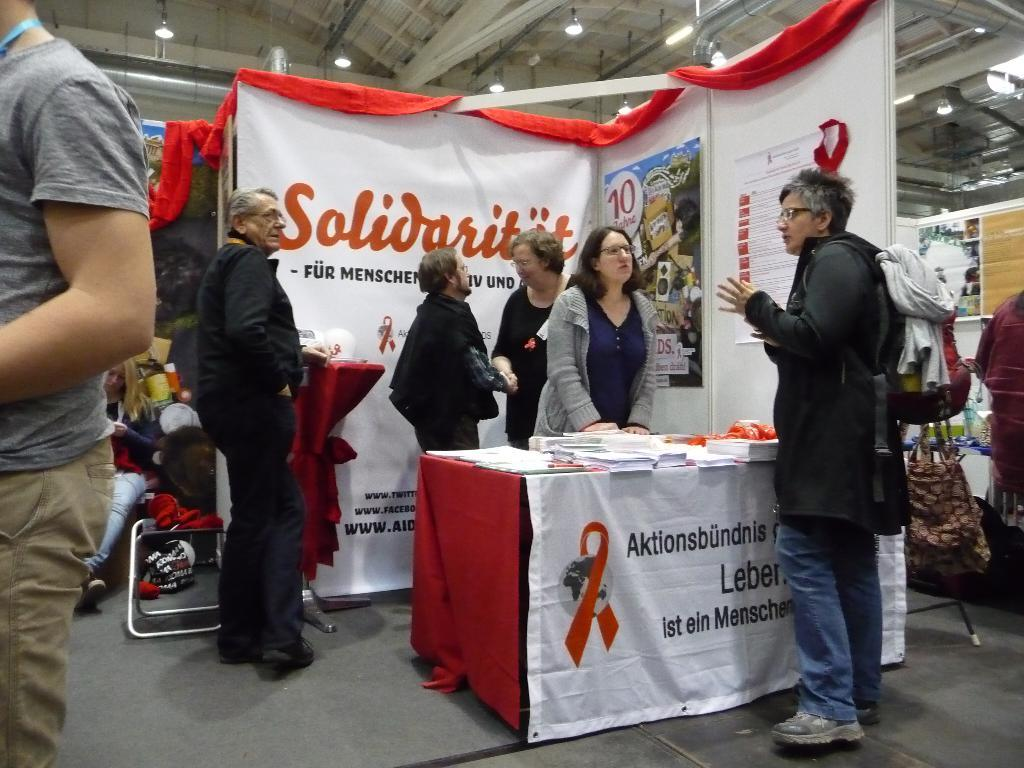What can be seen in the image involving people? There are people standing in the image. What objects are present in the image that might be used for seating or eating? There are tables in the image. What items are placed on the tables? Books are placed on the tables. What type of shelter is visible in the image? There is a tent in the image. What is the purpose of the board in the image? The purpose of the board in the image is not clear from the facts provided. What type of material is present in the image? There is cloth in the image. What type of container is visible in the image? There is a bag in the image. What is visible at the top of the image? Lights are visible at the top of the image. How many worms can be seen crawling on the bag in the image? There are no worms present in the image; the bag is the only item mentioned in the image. What type of unit is being used to measure the size of the tent in the image? There is no mention of any unit of measurement in the image or the provided facts. 